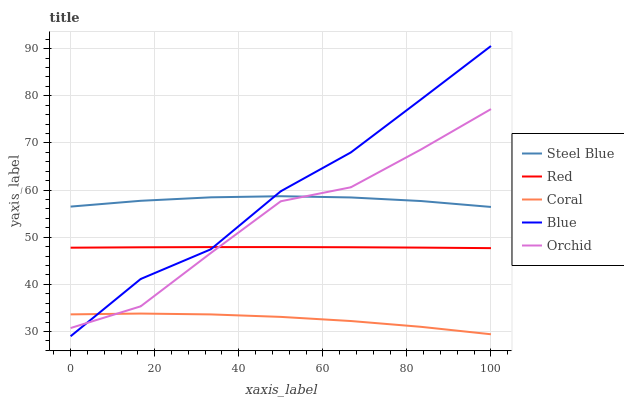Does Coral have the minimum area under the curve?
Answer yes or no. Yes. Does Blue have the maximum area under the curve?
Answer yes or no. Yes. Does Steel Blue have the minimum area under the curve?
Answer yes or no. No. Does Steel Blue have the maximum area under the curve?
Answer yes or no. No. Is Red the smoothest?
Answer yes or no. Yes. Is Orchid the roughest?
Answer yes or no. Yes. Is Coral the smoothest?
Answer yes or no. No. Is Coral the roughest?
Answer yes or no. No. Does Blue have the lowest value?
Answer yes or no. Yes. Does Coral have the lowest value?
Answer yes or no. No. Does Blue have the highest value?
Answer yes or no. Yes. Does Steel Blue have the highest value?
Answer yes or no. No. Is Coral less than Red?
Answer yes or no. Yes. Is Red greater than Coral?
Answer yes or no. Yes. Does Coral intersect Blue?
Answer yes or no. Yes. Is Coral less than Blue?
Answer yes or no. No. Is Coral greater than Blue?
Answer yes or no. No. Does Coral intersect Red?
Answer yes or no. No. 